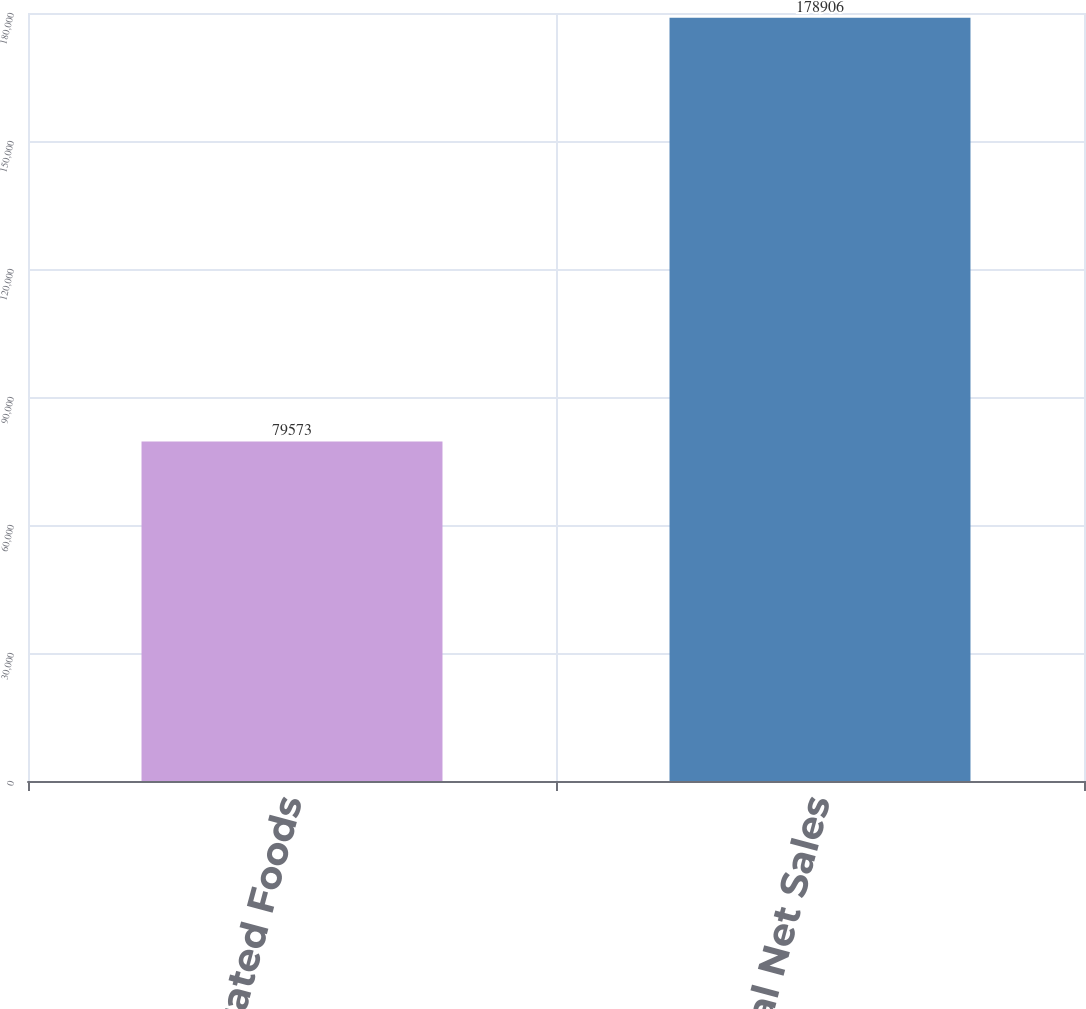Convert chart. <chart><loc_0><loc_0><loc_500><loc_500><bar_chart><fcel>Refrigerated Foods<fcel>Total Net Sales<nl><fcel>79573<fcel>178906<nl></chart> 